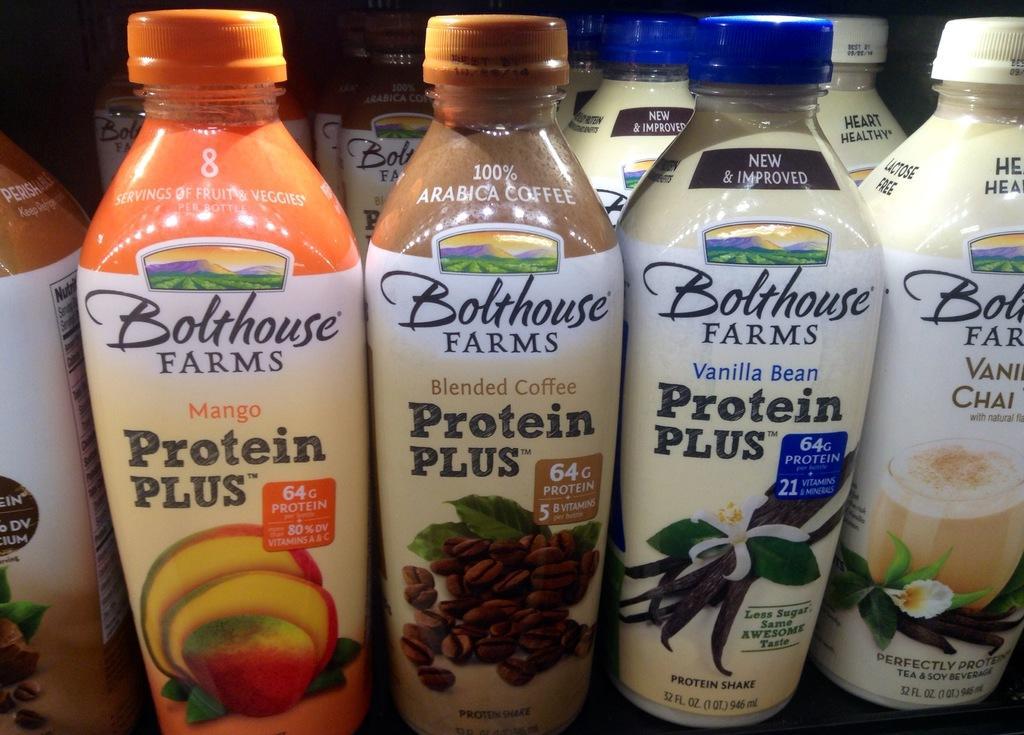Please provide a concise description of this image. In this picture we can see some bottles. 